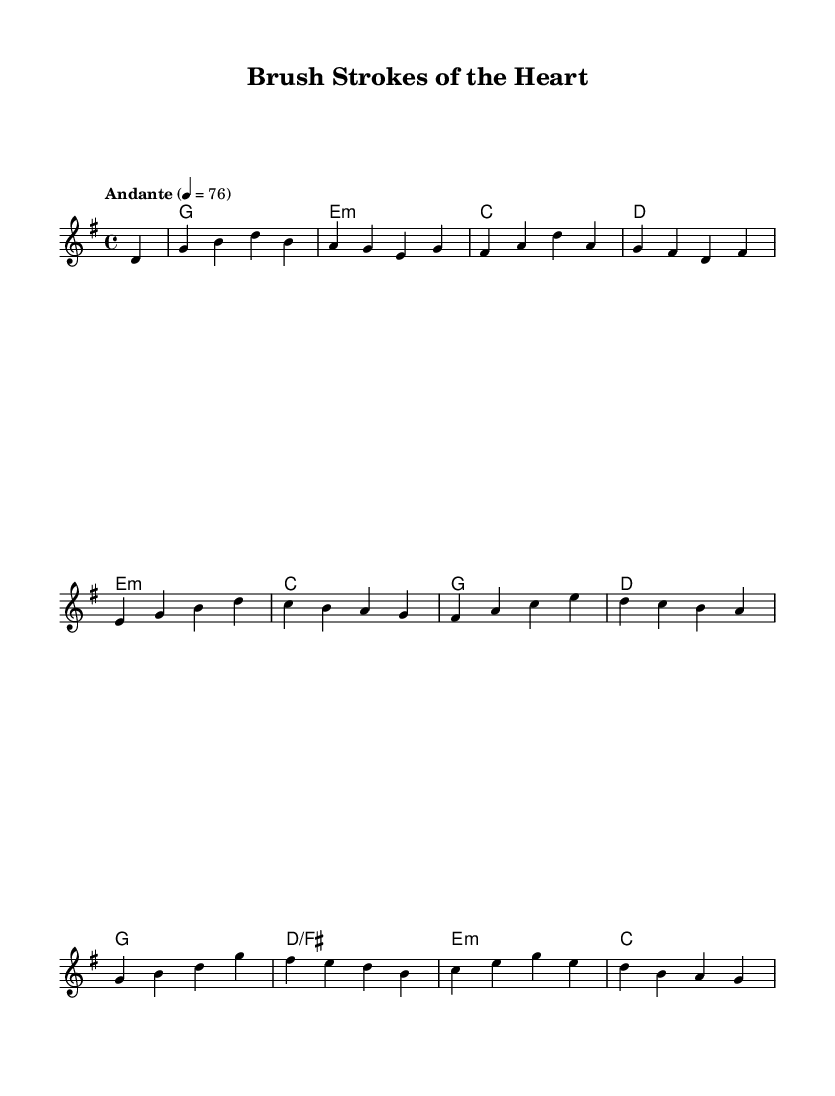What is the key signature of this music? The key signature is G major, which has one sharp (F#).
Answer: G major What is the time signature of this piece? The time signature is four-four, meaning there are four beats per measure.
Answer: Four-four What is the tempo marking of the piece? The tempo marking indicates "Andante" at a speed of 76 beats per minute.
Answer: Andante 76 How many measures are in the melody line? By counting the measures in the melody section, there are a total of 8 measures.
Answer: 8 What is the first note of the melody? The first note of the melody is D, and it is a quarter note.
Answer: D Which chord comes after the E minor in the harmony? After the E minor chord, the next chord is C major, as represented by the sequence.
Answer: C major How many different chords are used in this piece? The piece uses five different chords: G, E minor, C, D, and D/F#.
Answer: Five 